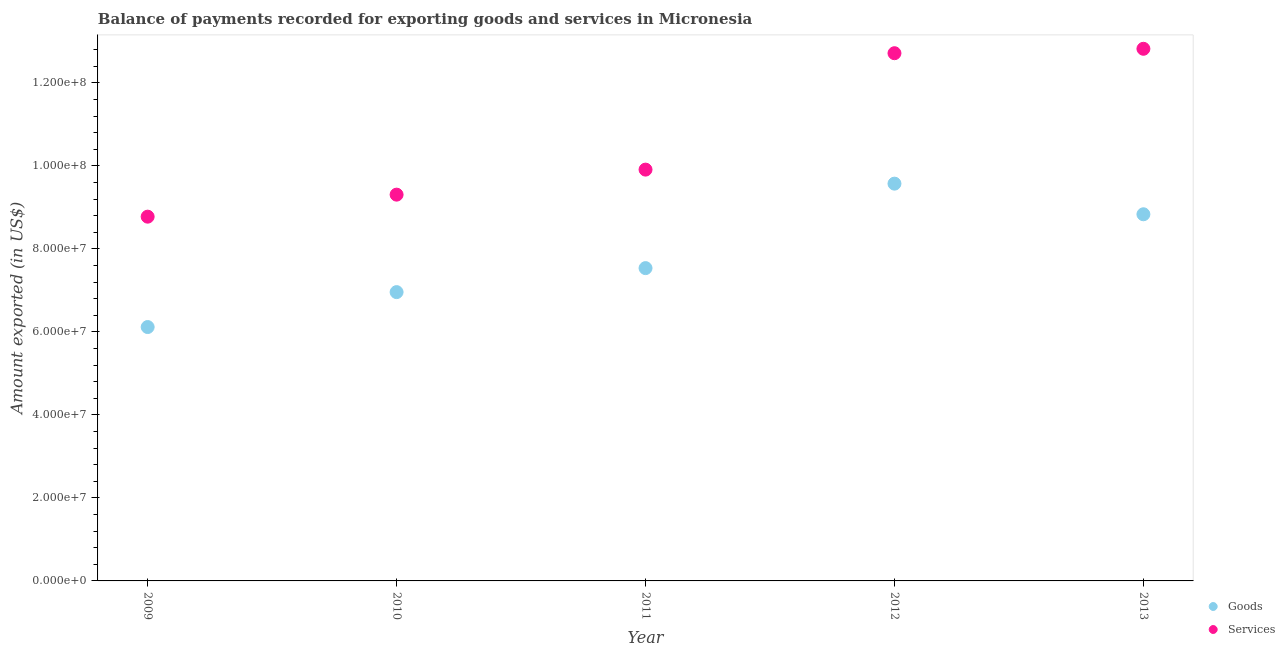Is the number of dotlines equal to the number of legend labels?
Your response must be concise. Yes. What is the amount of goods exported in 2010?
Provide a short and direct response. 6.96e+07. Across all years, what is the maximum amount of goods exported?
Offer a very short reply. 9.57e+07. Across all years, what is the minimum amount of services exported?
Your answer should be compact. 8.78e+07. In which year was the amount of services exported maximum?
Your answer should be very brief. 2013. What is the total amount of services exported in the graph?
Offer a terse response. 5.35e+08. What is the difference between the amount of goods exported in 2009 and that in 2010?
Provide a short and direct response. -8.42e+06. What is the difference between the amount of services exported in 2011 and the amount of goods exported in 2012?
Offer a very short reply. 3.38e+06. What is the average amount of goods exported per year?
Offer a terse response. 7.80e+07. In the year 2012, what is the difference between the amount of services exported and amount of goods exported?
Offer a terse response. 3.14e+07. What is the ratio of the amount of goods exported in 2009 to that in 2010?
Provide a succinct answer. 0.88. Is the difference between the amount of goods exported in 2009 and 2011 greater than the difference between the amount of services exported in 2009 and 2011?
Your answer should be very brief. No. What is the difference between the highest and the second highest amount of goods exported?
Provide a succinct answer. 7.38e+06. What is the difference between the highest and the lowest amount of services exported?
Provide a short and direct response. 4.05e+07. Is the sum of the amount of services exported in 2009 and 2012 greater than the maximum amount of goods exported across all years?
Your answer should be very brief. Yes. How many years are there in the graph?
Offer a terse response. 5. What is the difference between two consecutive major ticks on the Y-axis?
Give a very brief answer. 2.00e+07. Are the values on the major ticks of Y-axis written in scientific E-notation?
Your answer should be compact. Yes. Does the graph contain grids?
Your answer should be compact. No. Where does the legend appear in the graph?
Your answer should be very brief. Bottom right. How are the legend labels stacked?
Provide a short and direct response. Vertical. What is the title of the graph?
Give a very brief answer. Balance of payments recorded for exporting goods and services in Micronesia. Does "Male" appear as one of the legend labels in the graph?
Ensure brevity in your answer.  No. What is the label or title of the X-axis?
Ensure brevity in your answer.  Year. What is the label or title of the Y-axis?
Your answer should be compact. Amount exported (in US$). What is the Amount exported (in US$) of Goods in 2009?
Give a very brief answer. 6.12e+07. What is the Amount exported (in US$) in Services in 2009?
Keep it short and to the point. 8.78e+07. What is the Amount exported (in US$) in Goods in 2010?
Offer a terse response. 6.96e+07. What is the Amount exported (in US$) in Services in 2010?
Your answer should be very brief. 9.31e+07. What is the Amount exported (in US$) of Goods in 2011?
Give a very brief answer. 7.54e+07. What is the Amount exported (in US$) of Services in 2011?
Your answer should be compact. 9.91e+07. What is the Amount exported (in US$) in Goods in 2012?
Give a very brief answer. 9.57e+07. What is the Amount exported (in US$) in Services in 2012?
Your answer should be very brief. 1.27e+08. What is the Amount exported (in US$) of Goods in 2013?
Your answer should be compact. 8.83e+07. What is the Amount exported (in US$) in Services in 2013?
Provide a short and direct response. 1.28e+08. Across all years, what is the maximum Amount exported (in US$) of Goods?
Offer a terse response. 9.57e+07. Across all years, what is the maximum Amount exported (in US$) in Services?
Provide a succinct answer. 1.28e+08. Across all years, what is the minimum Amount exported (in US$) of Goods?
Provide a succinct answer. 6.12e+07. Across all years, what is the minimum Amount exported (in US$) in Services?
Your answer should be very brief. 8.78e+07. What is the total Amount exported (in US$) of Goods in the graph?
Provide a short and direct response. 3.90e+08. What is the total Amount exported (in US$) of Services in the graph?
Provide a succinct answer. 5.35e+08. What is the difference between the Amount exported (in US$) of Goods in 2009 and that in 2010?
Your answer should be compact. -8.42e+06. What is the difference between the Amount exported (in US$) in Services in 2009 and that in 2010?
Your answer should be compact. -5.31e+06. What is the difference between the Amount exported (in US$) of Goods in 2009 and that in 2011?
Make the answer very short. -1.42e+07. What is the difference between the Amount exported (in US$) in Services in 2009 and that in 2011?
Keep it short and to the point. -1.13e+07. What is the difference between the Amount exported (in US$) of Goods in 2009 and that in 2012?
Keep it short and to the point. -3.46e+07. What is the difference between the Amount exported (in US$) of Services in 2009 and that in 2012?
Your answer should be compact. -3.94e+07. What is the difference between the Amount exported (in US$) in Goods in 2009 and that in 2013?
Offer a very short reply. -2.72e+07. What is the difference between the Amount exported (in US$) of Services in 2009 and that in 2013?
Provide a succinct answer. -4.05e+07. What is the difference between the Amount exported (in US$) of Goods in 2010 and that in 2011?
Offer a very short reply. -5.78e+06. What is the difference between the Amount exported (in US$) of Services in 2010 and that in 2011?
Offer a very short reply. -6.03e+06. What is the difference between the Amount exported (in US$) in Goods in 2010 and that in 2012?
Offer a terse response. -2.61e+07. What is the difference between the Amount exported (in US$) in Services in 2010 and that in 2012?
Make the answer very short. -3.41e+07. What is the difference between the Amount exported (in US$) of Goods in 2010 and that in 2013?
Your response must be concise. -1.88e+07. What is the difference between the Amount exported (in US$) in Services in 2010 and that in 2013?
Provide a succinct answer. -3.51e+07. What is the difference between the Amount exported (in US$) in Goods in 2011 and that in 2012?
Offer a terse response. -2.04e+07. What is the difference between the Amount exported (in US$) in Services in 2011 and that in 2012?
Provide a succinct answer. -2.81e+07. What is the difference between the Amount exported (in US$) of Goods in 2011 and that in 2013?
Your answer should be very brief. -1.30e+07. What is the difference between the Amount exported (in US$) of Services in 2011 and that in 2013?
Your answer should be compact. -2.91e+07. What is the difference between the Amount exported (in US$) of Goods in 2012 and that in 2013?
Provide a short and direct response. 7.38e+06. What is the difference between the Amount exported (in US$) of Services in 2012 and that in 2013?
Provide a short and direct response. -1.06e+06. What is the difference between the Amount exported (in US$) of Goods in 2009 and the Amount exported (in US$) of Services in 2010?
Your response must be concise. -3.19e+07. What is the difference between the Amount exported (in US$) in Goods in 2009 and the Amount exported (in US$) in Services in 2011?
Give a very brief answer. -3.79e+07. What is the difference between the Amount exported (in US$) in Goods in 2009 and the Amount exported (in US$) in Services in 2012?
Your response must be concise. -6.60e+07. What is the difference between the Amount exported (in US$) in Goods in 2009 and the Amount exported (in US$) in Services in 2013?
Your response must be concise. -6.70e+07. What is the difference between the Amount exported (in US$) of Goods in 2010 and the Amount exported (in US$) of Services in 2011?
Provide a short and direct response. -2.95e+07. What is the difference between the Amount exported (in US$) in Goods in 2010 and the Amount exported (in US$) in Services in 2012?
Provide a succinct answer. -5.76e+07. What is the difference between the Amount exported (in US$) of Goods in 2010 and the Amount exported (in US$) of Services in 2013?
Provide a short and direct response. -5.86e+07. What is the difference between the Amount exported (in US$) in Goods in 2011 and the Amount exported (in US$) in Services in 2012?
Your answer should be very brief. -5.18e+07. What is the difference between the Amount exported (in US$) of Goods in 2011 and the Amount exported (in US$) of Services in 2013?
Give a very brief answer. -5.28e+07. What is the difference between the Amount exported (in US$) of Goods in 2012 and the Amount exported (in US$) of Services in 2013?
Provide a succinct answer. -3.25e+07. What is the average Amount exported (in US$) in Goods per year?
Offer a very short reply. 7.80e+07. What is the average Amount exported (in US$) of Services per year?
Your answer should be compact. 1.07e+08. In the year 2009, what is the difference between the Amount exported (in US$) of Goods and Amount exported (in US$) of Services?
Your response must be concise. -2.66e+07. In the year 2010, what is the difference between the Amount exported (in US$) in Goods and Amount exported (in US$) in Services?
Keep it short and to the point. -2.35e+07. In the year 2011, what is the difference between the Amount exported (in US$) in Goods and Amount exported (in US$) in Services?
Make the answer very short. -2.37e+07. In the year 2012, what is the difference between the Amount exported (in US$) of Goods and Amount exported (in US$) of Services?
Provide a short and direct response. -3.14e+07. In the year 2013, what is the difference between the Amount exported (in US$) of Goods and Amount exported (in US$) of Services?
Offer a terse response. -3.99e+07. What is the ratio of the Amount exported (in US$) in Goods in 2009 to that in 2010?
Your answer should be compact. 0.88. What is the ratio of the Amount exported (in US$) in Services in 2009 to that in 2010?
Provide a short and direct response. 0.94. What is the ratio of the Amount exported (in US$) in Goods in 2009 to that in 2011?
Offer a very short reply. 0.81. What is the ratio of the Amount exported (in US$) of Services in 2009 to that in 2011?
Offer a very short reply. 0.89. What is the ratio of the Amount exported (in US$) in Goods in 2009 to that in 2012?
Keep it short and to the point. 0.64. What is the ratio of the Amount exported (in US$) in Services in 2009 to that in 2012?
Provide a short and direct response. 0.69. What is the ratio of the Amount exported (in US$) of Goods in 2009 to that in 2013?
Provide a short and direct response. 0.69. What is the ratio of the Amount exported (in US$) in Services in 2009 to that in 2013?
Make the answer very short. 0.68. What is the ratio of the Amount exported (in US$) in Goods in 2010 to that in 2011?
Your answer should be very brief. 0.92. What is the ratio of the Amount exported (in US$) in Services in 2010 to that in 2011?
Ensure brevity in your answer.  0.94. What is the ratio of the Amount exported (in US$) of Goods in 2010 to that in 2012?
Ensure brevity in your answer.  0.73. What is the ratio of the Amount exported (in US$) in Services in 2010 to that in 2012?
Your answer should be compact. 0.73. What is the ratio of the Amount exported (in US$) of Goods in 2010 to that in 2013?
Your answer should be very brief. 0.79. What is the ratio of the Amount exported (in US$) in Services in 2010 to that in 2013?
Provide a short and direct response. 0.73. What is the ratio of the Amount exported (in US$) in Goods in 2011 to that in 2012?
Provide a short and direct response. 0.79. What is the ratio of the Amount exported (in US$) in Services in 2011 to that in 2012?
Offer a terse response. 0.78. What is the ratio of the Amount exported (in US$) in Goods in 2011 to that in 2013?
Your answer should be compact. 0.85. What is the ratio of the Amount exported (in US$) in Services in 2011 to that in 2013?
Provide a succinct answer. 0.77. What is the ratio of the Amount exported (in US$) of Goods in 2012 to that in 2013?
Make the answer very short. 1.08. What is the ratio of the Amount exported (in US$) in Services in 2012 to that in 2013?
Ensure brevity in your answer.  0.99. What is the difference between the highest and the second highest Amount exported (in US$) in Goods?
Your answer should be very brief. 7.38e+06. What is the difference between the highest and the second highest Amount exported (in US$) of Services?
Ensure brevity in your answer.  1.06e+06. What is the difference between the highest and the lowest Amount exported (in US$) in Goods?
Your answer should be compact. 3.46e+07. What is the difference between the highest and the lowest Amount exported (in US$) of Services?
Make the answer very short. 4.05e+07. 